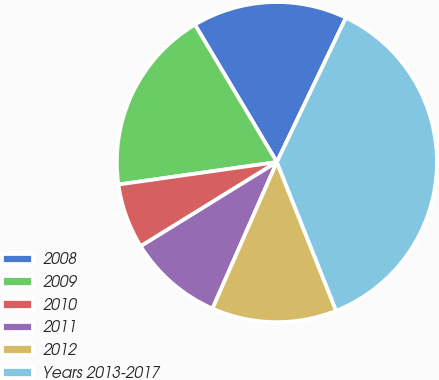Convert chart. <chart><loc_0><loc_0><loc_500><loc_500><pie_chart><fcel>2008<fcel>2009<fcel>2010<fcel>2011<fcel>2012<fcel>Years 2013-2017<nl><fcel>15.66%<fcel>18.69%<fcel>6.57%<fcel>9.6%<fcel>12.63%<fcel>36.87%<nl></chart> 